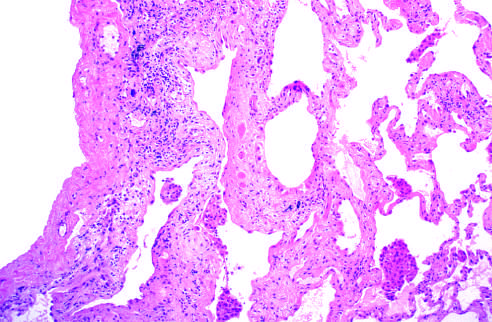s failure to stain more pronounced in the subpleural region?
Answer the question using a single word or phrase. No 